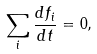Convert formula to latex. <formula><loc_0><loc_0><loc_500><loc_500>\sum _ { i } \frac { d f _ { i } } { d t } = 0 ,</formula> 